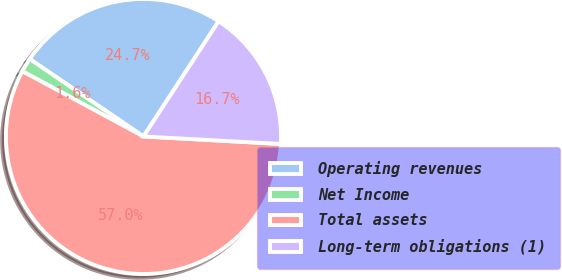<chart> <loc_0><loc_0><loc_500><loc_500><pie_chart><fcel>Operating revenues<fcel>Net Income<fcel>Total assets<fcel>Long-term obligations (1)<nl><fcel>24.69%<fcel>1.65%<fcel>57.0%<fcel>16.67%<nl></chart> 